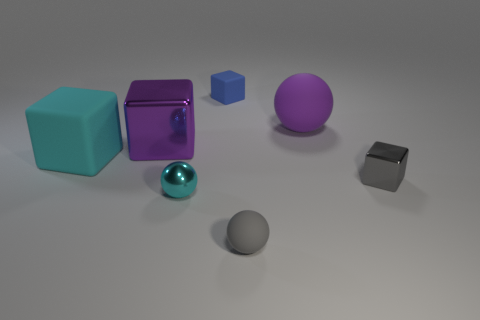There is a big matte object that is the same color as the large shiny cube; what shape is it? sphere 